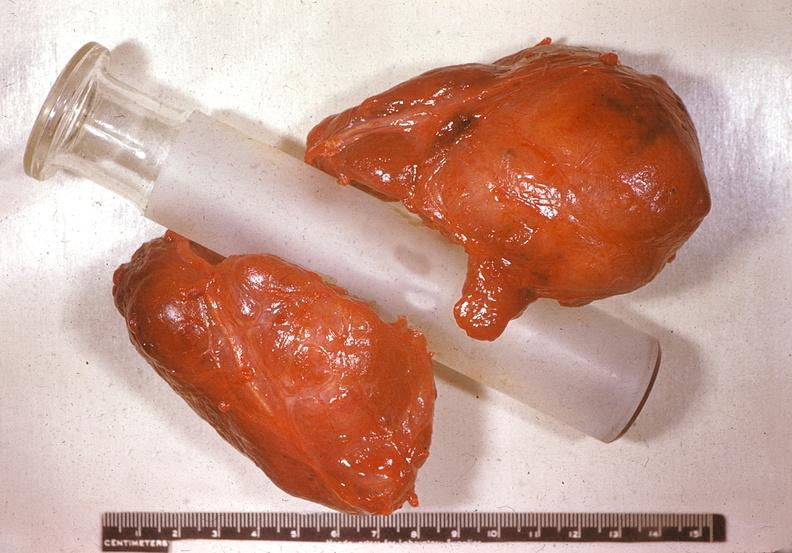s endocrine present?
Answer the question using a single word or phrase. Yes 